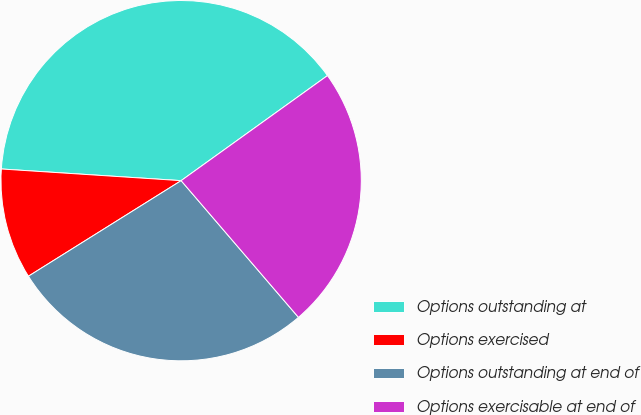<chart> <loc_0><loc_0><loc_500><loc_500><pie_chart><fcel>Options outstanding at<fcel>Options exercised<fcel>Options outstanding at end of<fcel>Options exercisable at end of<nl><fcel>39.06%<fcel>9.93%<fcel>27.39%<fcel>23.62%<nl></chart> 